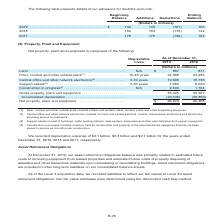According to Centurylink's financial document, What does 'Fiber, conduit and other outside plant' consist of? fiber and metallic cable, conduit, poles and other supporting structures. The document states: "iber, conduit and other outside plant consists of fiber and metallic cable, conduit, poles and other supporting structures...." Also, What do 'Support assets' consist of? buildings, cable landing stations, data centers, computers and other administrative and support equipment.. The document states: "(3) Support assets consist of buildings, cable landing stations, data centers, computers and other administrative and support equipment...." Also, In which years was the depreciation expense recorded? The document contains multiple relevant values: 2019, 2018, 2017. From the document: "19 . $ 142 145 (181) 106 2018 . 164 153 (175) 142 2017 . 178 176 (190) 164 (Dollars in millions) 2019 . $ 142 145 (181) 106 2018 . 164 153 (175) 142 2..." Additionally, In which year was the depreciation expense recorded the largest? According to the financial document, 2018. The relevant text states: "(Dollars in millions) 2019 . $ 142 145 (181) 106 2018 . 164 153 (175) 142 2017 . 178 176 (190) 164..." Also, can you calculate: What is the change in the construction in progress in 2019? Based on the calculation: 2,300-1,704, the result is 596 (in millions). This is based on the information: "84 8,020 Construction in progress (4) . N/A 2,300 1,704 rs 7,984 8,020 Construction in progress (4) . N/A 2,300 1,704..." The key data points involved are: 1,704, 2,300. Also, can you calculate: What is the average net property, plant and equipment? To answer this question, I need to perform calculations using the financial data. The calculation is: (26,079+26,408)/2, which equals 26243.5 (in millions). This is based on the information: "Net property, plant and equipment . $ 26,079 26,408 Net property, plant and equipment . $ 26,079 26,408..." The key data points involved are: 26,079, 26,408. 